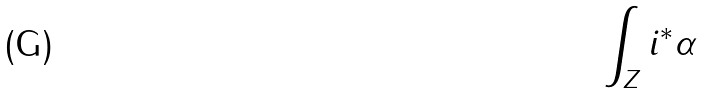Convert formula to latex. <formula><loc_0><loc_0><loc_500><loc_500>\int _ { Z } i ^ { * } \alpha</formula> 